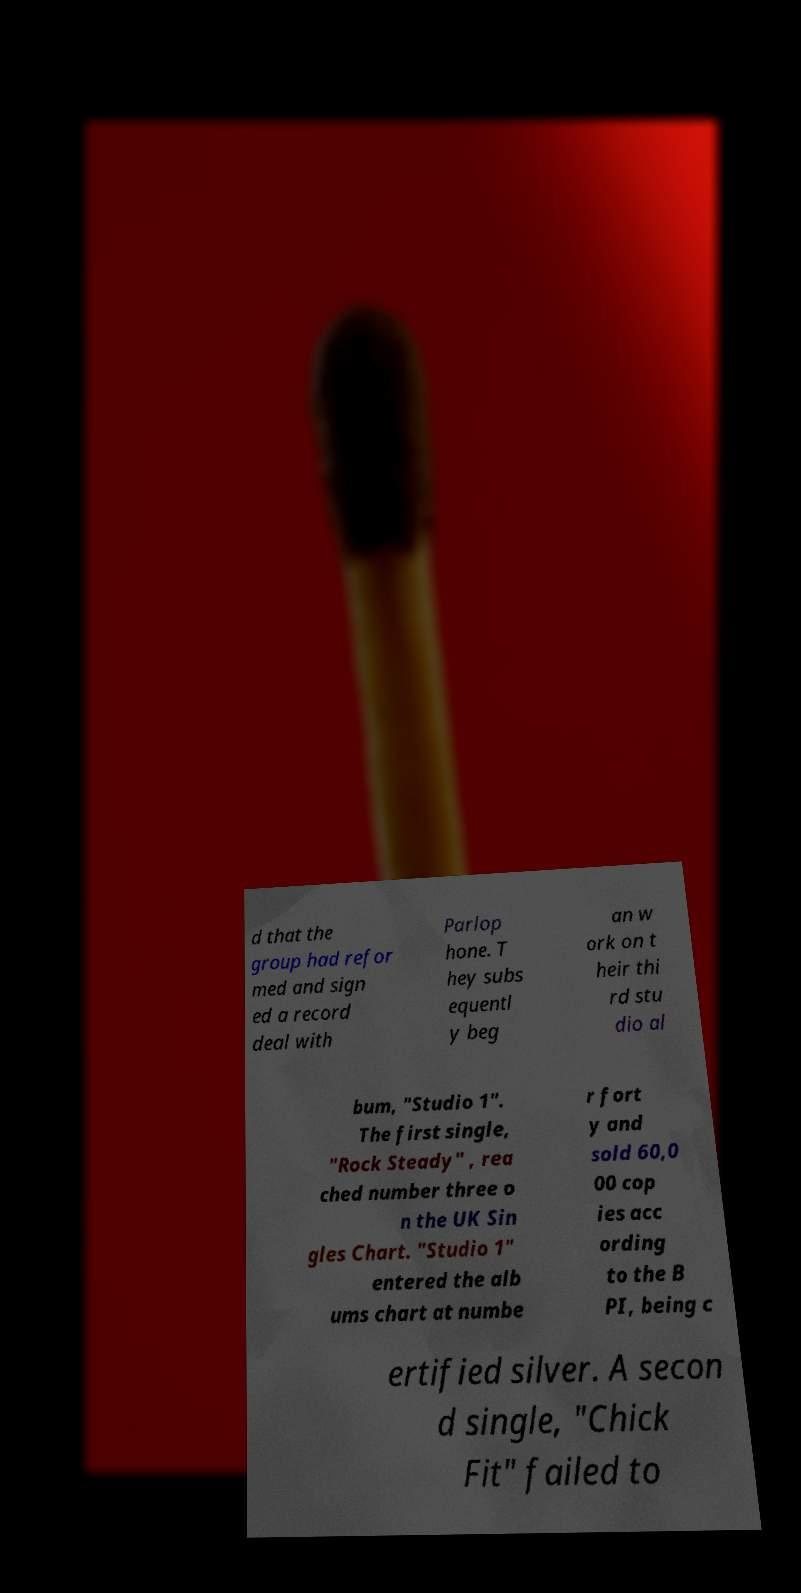Please identify and transcribe the text found in this image. d that the group had refor med and sign ed a record deal with Parlop hone. T hey subs equentl y beg an w ork on t heir thi rd stu dio al bum, "Studio 1". The first single, "Rock Steady" , rea ched number three o n the UK Sin gles Chart. "Studio 1" entered the alb ums chart at numbe r fort y and sold 60,0 00 cop ies acc ording to the B PI, being c ertified silver. A secon d single, "Chick Fit" failed to 